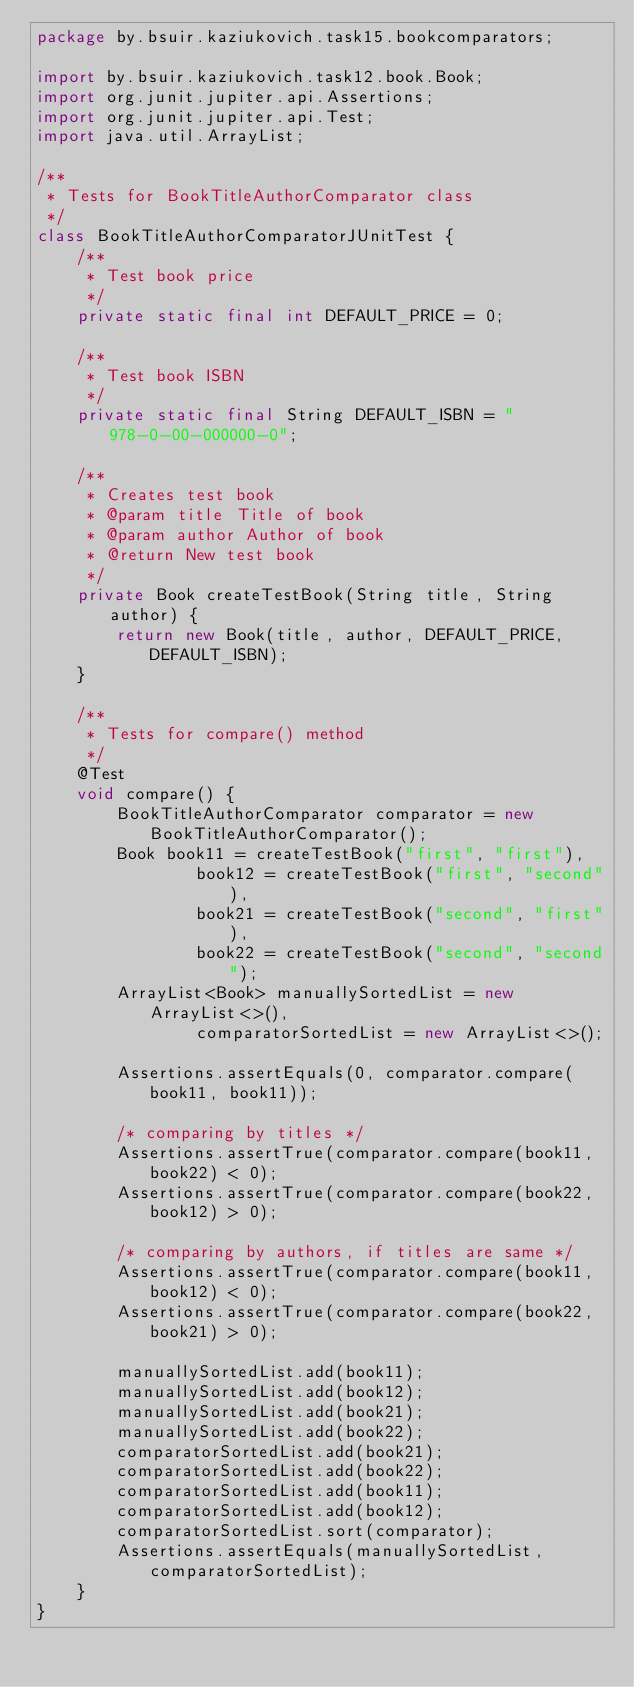<code> <loc_0><loc_0><loc_500><loc_500><_Java_>package by.bsuir.kaziukovich.task15.bookcomparators;

import by.bsuir.kaziukovich.task12.book.Book;
import org.junit.jupiter.api.Assertions;
import org.junit.jupiter.api.Test;
import java.util.ArrayList;

/**
 * Tests for BookTitleAuthorComparator class
 */
class BookTitleAuthorComparatorJUnitTest {
    /**
     * Test book price
     */
    private static final int DEFAULT_PRICE = 0;

    /**
     * Test book ISBN
     */
    private static final String DEFAULT_ISBN = "978-0-00-000000-0";

    /**
     * Creates test book
     * @param title Title of book
     * @param author Author of book
     * @return New test book
     */
    private Book createTestBook(String title, String author) {
        return new Book(title, author, DEFAULT_PRICE, DEFAULT_ISBN);
    }

    /**
     * Tests for compare() method
     */
    @Test
    void compare() {
        BookTitleAuthorComparator comparator = new BookTitleAuthorComparator();
        Book book11 = createTestBook("first", "first"),
                book12 = createTestBook("first", "second"),
                book21 = createTestBook("second", "first"),
                book22 = createTestBook("second", "second");
        ArrayList<Book> manuallySortedList = new ArrayList<>(),
                comparatorSortedList = new ArrayList<>();

        Assertions.assertEquals(0, comparator.compare(book11, book11));

        /* comparing by titles */
        Assertions.assertTrue(comparator.compare(book11, book22) < 0);
        Assertions.assertTrue(comparator.compare(book22, book12) > 0);

        /* comparing by authors, if titles are same */
        Assertions.assertTrue(comparator.compare(book11, book12) < 0);
        Assertions.assertTrue(comparator.compare(book22, book21) > 0);

        manuallySortedList.add(book11);
        manuallySortedList.add(book12);
        manuallySortedList.add(book21);
        manuallySortedList.add(book22);
        comparatorSortedList.add(book21);
        comparatorSortedList.add(book22);
        comparatorSortedList.add(book11);
        comparatorSortedList.add(book12);
        comparatorSortedList.sort(comparator);
        Assertions.assertEquals(manuallySortedList, comparatorSortedList);
    }
}</code> 